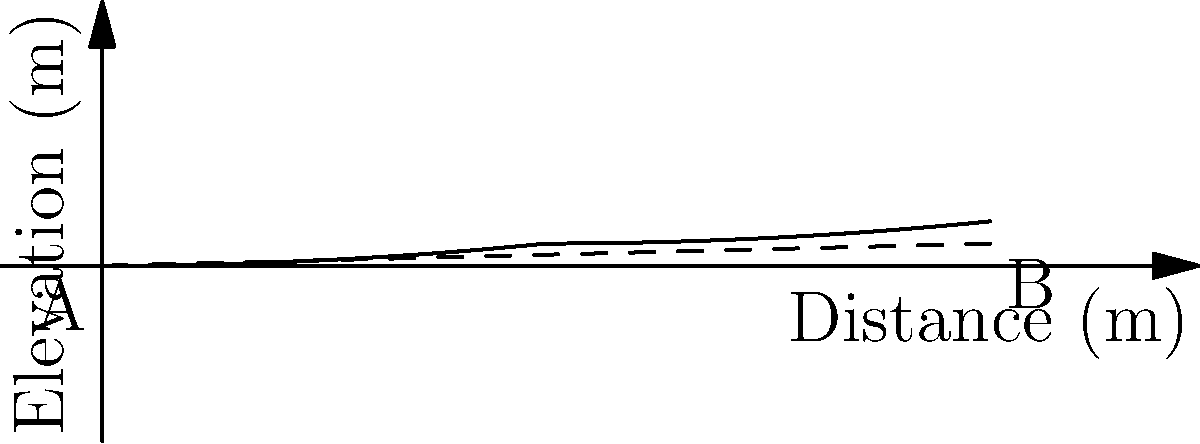As a biomedical engineer working on haptic technology for the visually impaired, you're developing a system to represent fluid flow through pipes using tactile feedback. Consider a circular pipe with a diameter of 0.3 meters connecting points A and B as shown in the figure. The pipe follows the curved path, and the straight-line distance between A and B is 20 meters with an elevation difference of 0.5 meters. Calculate the flow rate through the pipe in $\text{m}^3/\text{s}$ if the Darcy-Weisbach friction factor is 0.02 and the kinematic viscosity of the fluid is $1 \times 10^{-6} \text{ m}^2/\text{s}$. To solve this problem, we'll follow these steps:

1) Calculate the hydraulic gradient:
   Hydraulic gradient = Elevation difference / Straight-line distance
   $I = \frac{0.5 \text{ m}}{20 \text{ m}} = 0.025$

2) Use the Darcy-Weisbach equation to find the velocity:
   $I = \frac{f}{D} \cdot \frac{v^2}{2g}$

   Where:
   $I$ = hydraulic gradient
   $f$ = friction factor = 0.02
   $D$ = pipe diameter = 0.3 m
   $g$ = acceleration due to gravity = 9.81 m/s²

   Rearranging for $v$:
   $v = \sqrt{\frac{2gID}{f}} = \sqrt{\frac{2 \cdot 9.81 \cdot 0.025 \cdot 0.3}{0.02}} = 3.82 \text{ m/s}$

3) Calculate the flow rate:
   $Q = A \cdot v$
   Where $A$ is the cross-sectional area of the pipe:
   $A = \pi r^2 = \pi (0.15 \text{ m})^2 = 0.0707 \text{ m}^2$

   Therefore:
   $Q = 0.0707 \text{ m}^2 \cdot 3.82 \text{ m/s} = 0.270 \text{ m}^3/\text{s}$

4) Check if the flow is turbulent:
   Reynolds number $Re = \frac{vD}{\nu} = \frac{3.82 \cdot 0.3}{1 \times 10^{-6}} = 1.146 \times 10^6$
   This is well above 4000, confirming turbulent flow and validating our use of the Darcy-Weisbach equation.
Answer: $0.270 \text{ m}^3/\text{s}$ 